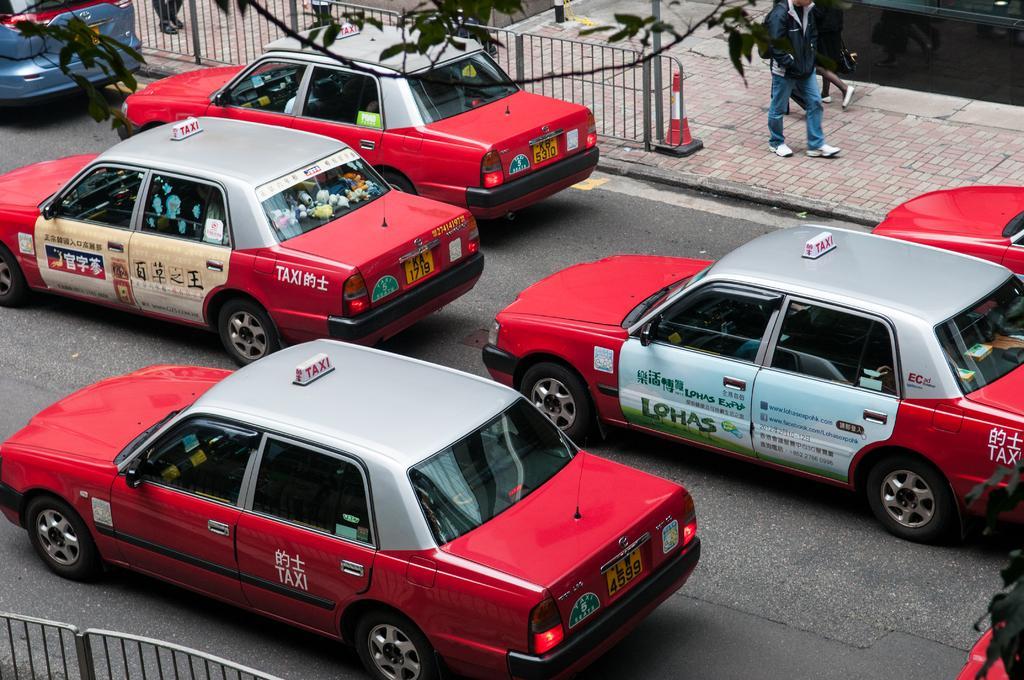Describe this image in one or two sentences. In this image we can see there are few cars on the road. On the left and right side of the road there is a railing and few persons are walking on the pavement. At the top of the image we can see the leaves of a tree. 